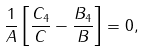Convert formula to latex. <formula><loc_0><loc_0><loc_500><loc_500>\frac { 1 } { A } \left [ \frac { C _ { 4 } } { C } - \frac { B _ { 4 } } { B } \right ] = 0 ,</formula> 